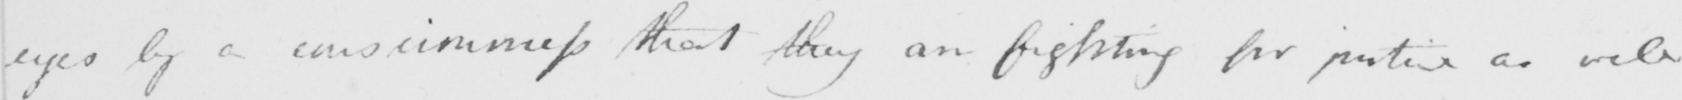Please transcribe the handwritten text in this image. eyes by a consciousness that they are fighting for justice as well 